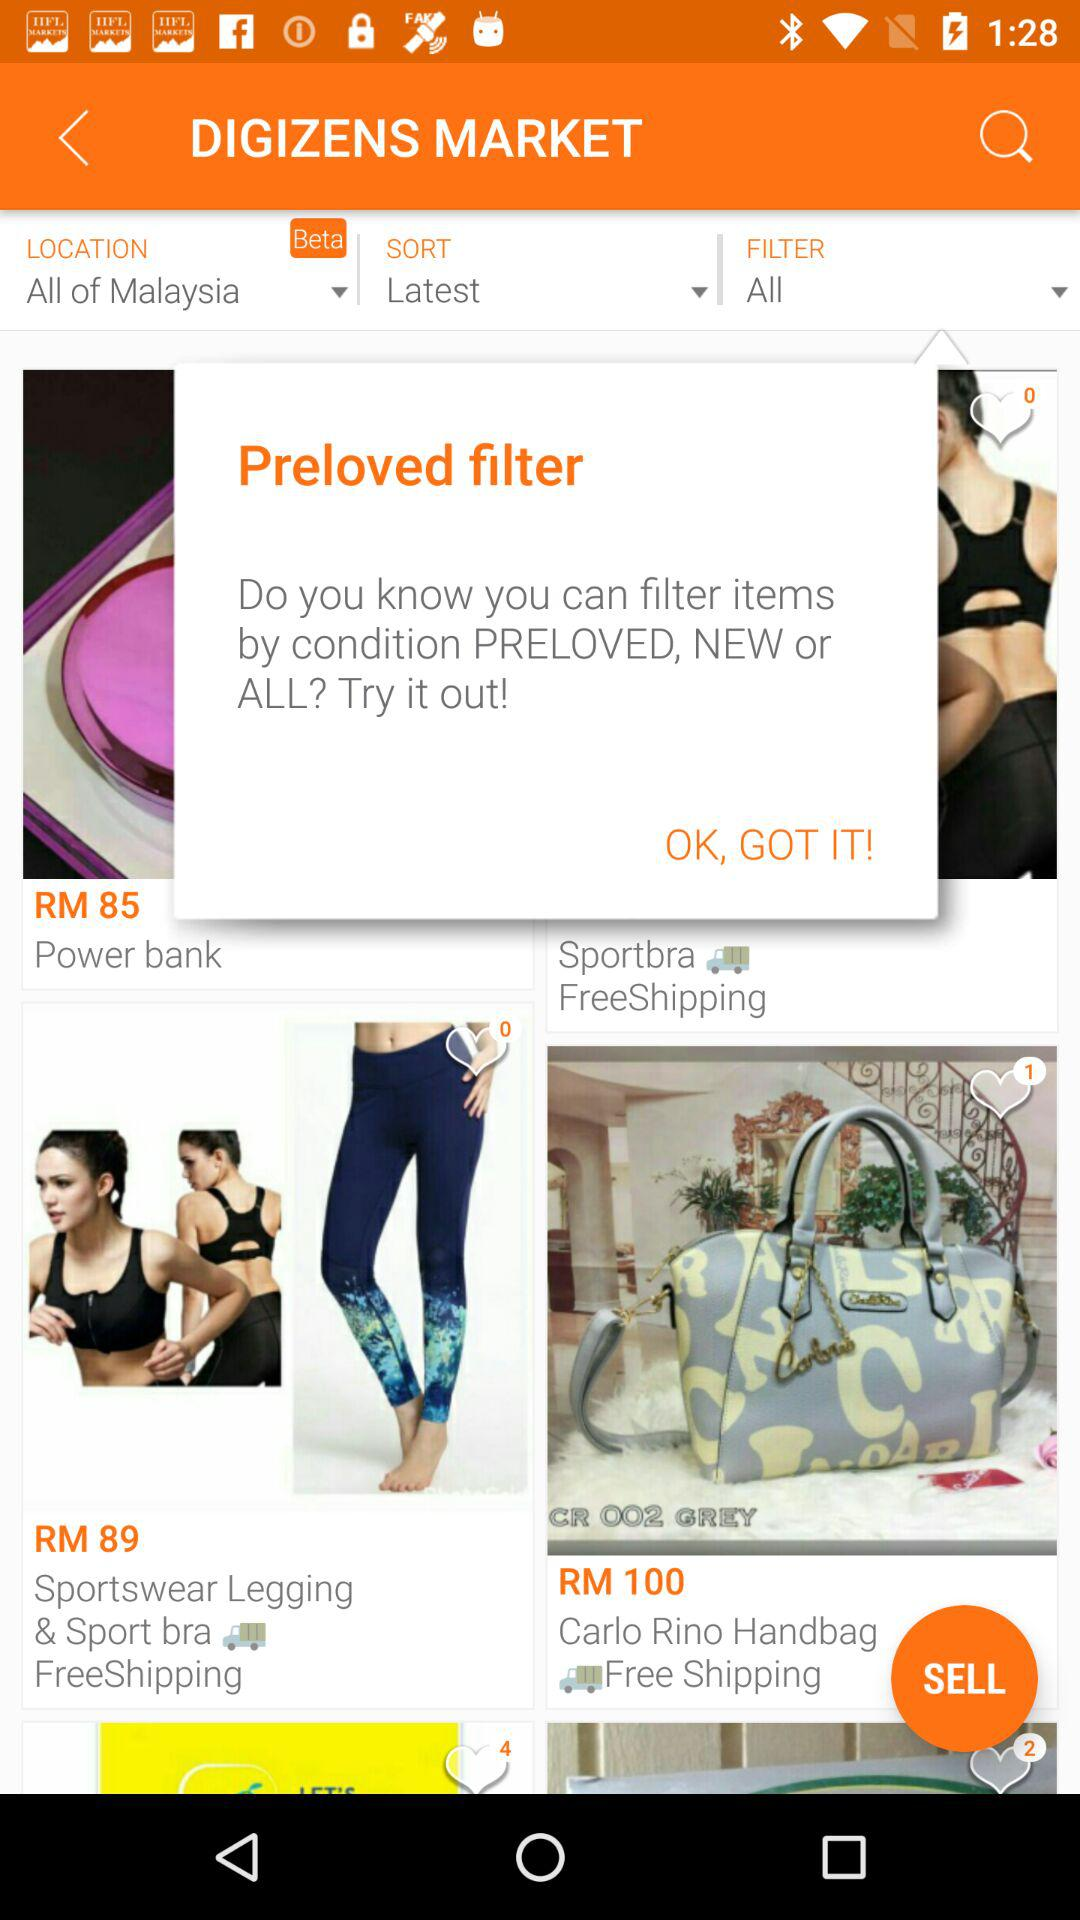What is the price of the Sportswear Leggings? The price is RM 89. 